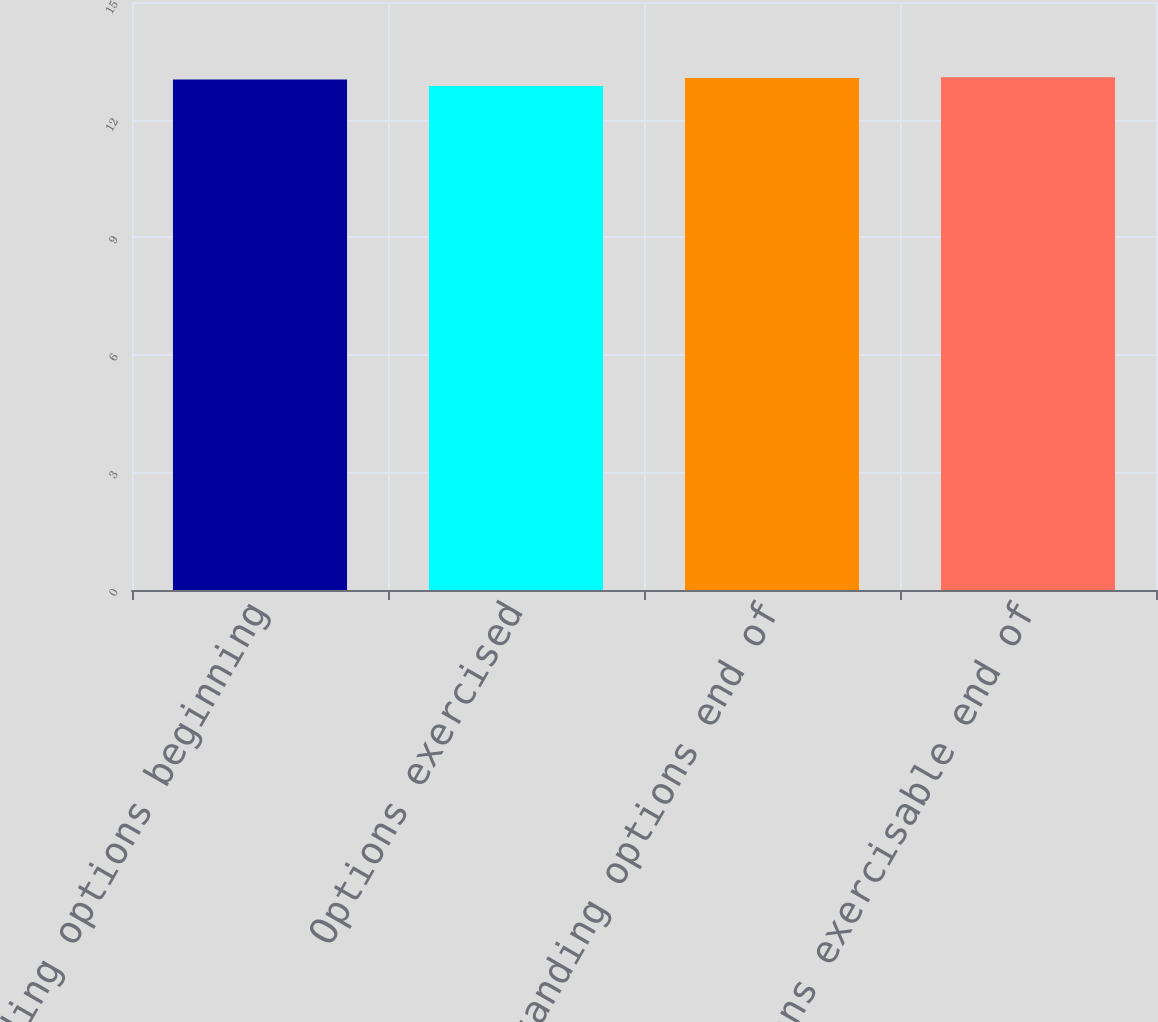Convert chart to OTSL. <chart><loc_0><loc_0><loc_500><loc_500><bar_chart><fcel>Outstanding options beginning<fcel>Options exercised<fcel>Outstanding options end of<fcel>Options exercisable end of<nl><fcel>13.02<fcel>12.86<fcel>13.06<fcel>13.08<nl></chart> 